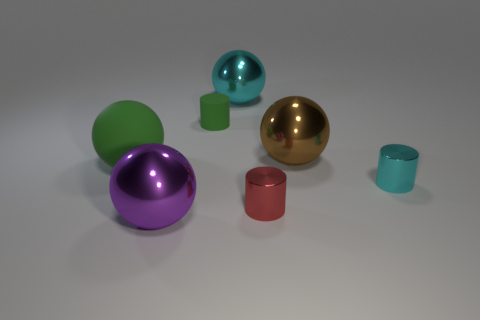How many objects in total are displayed in this image, and can you categorize them by shape? In total, there are seven objects. There are three spheres, two cylinders, and two cubes. Each object exhibits its own unique color and texture, ranging from matte to shiny surfaces. What colors are the cubes? The cubes are colored differently; one is green and the other is magenta. 